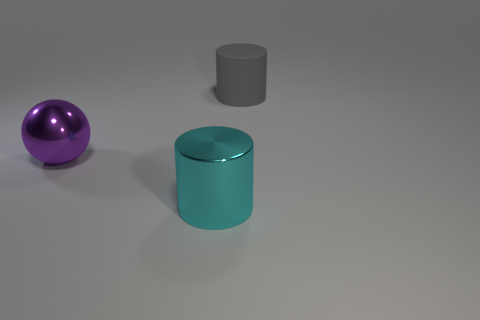Is there any other thing that is made of the same material as the large gray cylinder?
Offer a terse response. No. What shape is the other purple object that is the same size as the matte object?
Your answer should be very brief. Sphere. Are there fewer rubber things than metallic objects?
Your answer should be compact. Yes. Is there a large purple shiny sphere in front of the object that is behind the big purple ball?
Your response must be concise. Yes. There is a large cyan thing that is made of the same material as the purple object; what shape is it?
Ensure brevity in your answer.  Cylinder. Is there anything else that has the same color as the big matte object?
Keep it short and to the point. No. There is another thing that is the same shape as the cyan object; what is it made of?
Provide a succinct answer. Rubber. How many other objects are there of the same size as the gray cylinder?
Give a very brief answer. 2. Is the shape of the shiny object that is to the left of the big cyan metal cylinder the same as  the gray rubber object?
Keep it short and to the point. No. How many other objects are the same shape as the rubber thing?
Your answer should be compact. 1. 